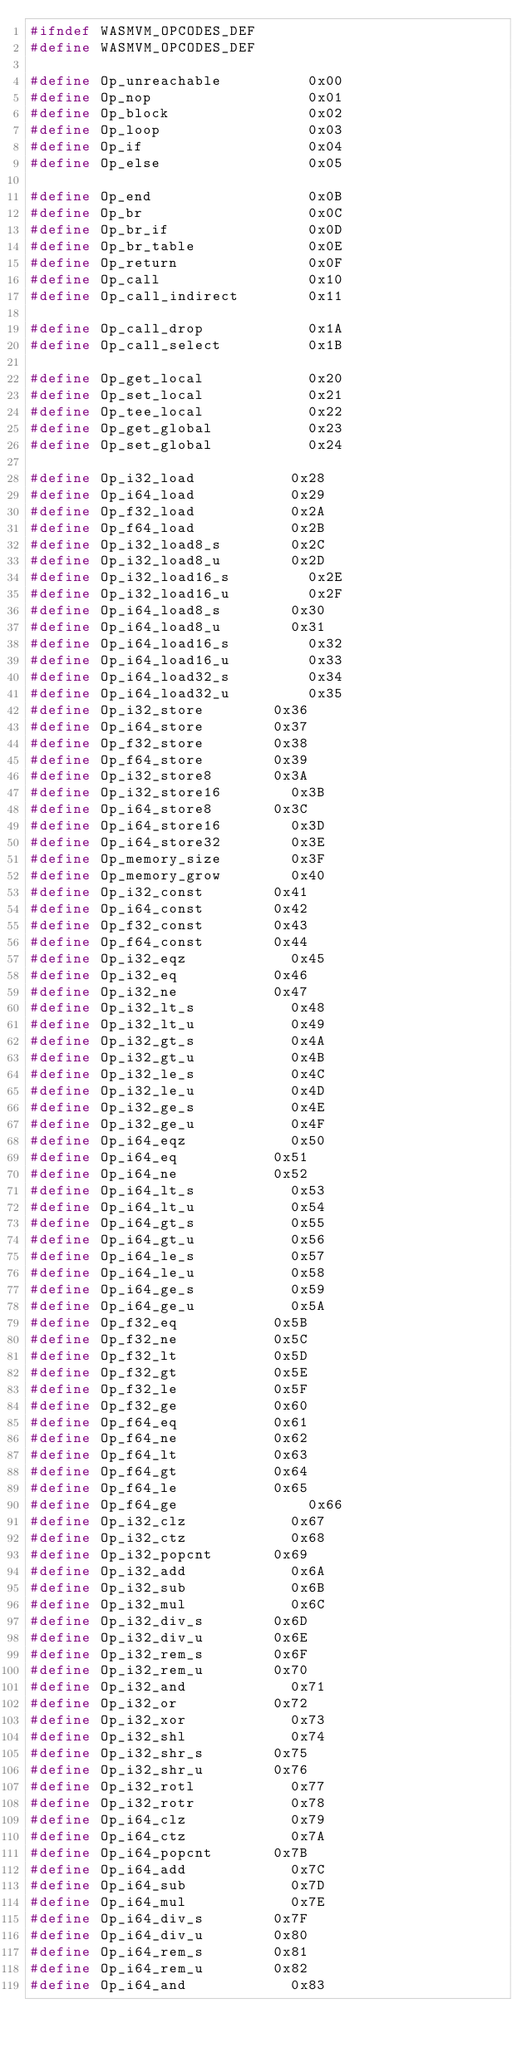<code> <loc_0><loc_0><loc_500><loc_500><_C_>#ifndef WASMVM_OPCODES_DEF
#define WASMVM_OPCODES_DEF

#define Op_unreachable          0x00
#define Op_nop                  0x01
#define Op_block                0x02
#define Op_loop                 0x03
#define Op_if                   0x04
#define Op_else                 0x05

#define Op_end                  0x0B
#define Op_br                   0x0C
#define Op_br_if                0x0D
#define Op_br_table             0x0E
#define Op_return               0x0F
#define Op_call                 0x10
#define Op_call_indirect        0x11

#define Op_call_drop            0x1A
#define Op_call_select          0x1B

#define Op_get_local            0x20
#define Op_set_local            0x21
#define Op_tee_local            0x22
#define Op_get_global           0x23
#define Op_set_global           0x24

#define Op_i32_load		        0x28
#define Op_i64_load		        0x29
#define Op_f32_load		        0x2A
#define Op_f64_load		        0x2B
#define Op_i32_load8_s		    0x2C
#define Op_i32_load8_u		    0x2D
#define Op_i32_load16_s	        0x2E
#define Op_i32_load16_u	        0x2F
#define Op_i64_load8_s		    0x30
#define Op_i64_load8_u		    0x31
#define Op_i64_load16_s	        0x32
#define Op_i64_load16_u	        0x33
#define Op_i64_load32_s	        0x34
#define Op_i64_load32_u	        0x35
#define Op_i32_store		    0x36
#define Op_i64_store		    0x37
#define Op_f32_store		    0x38
#define Op_f64_store		    0x39
#define Op_i32_store8		    0x3A
#define Op_i32_store16		    0x3B
#define Op_i64_store8		    0x3C
#define Op_i64_store16		    0x3D
#define Op_i64_store32		    0x3E
#define Op_memory_size		    0x3F
#define Op_memory_grow		    0x40
#define Op_i32_const		    0x41
#define Op_i64_const		    0x42
#define Op_f32_const		    0x43
#define Op_f64_const		    0x44
#define Op_i32_eqz		        0x45
#define Op_i32_eq		        0x46
#define Op_i32_ne		        0x47
#define Op_i32_lt_s		        0x48
#define Op_i32_lt_u		        0x49
#define Op_i32_gt_s		        0x4A
#define Op_i32_gt_u		        0x4B
#define Op_i32_le_s		        0x4C
#define Op_i32_le_u		        0x4D
#define Op_i32_ge_s		        0x4E
#define Op_i32_ge_u		        0x4F
#define Op_i64_eqz		        0x50
#define Op_i64_eq		        0x51
#define Op_i64_ne		        0x52
#define Op_i64_lt_s		        0x53
#define Op_i64_lt_u		        0x54
#define Op_i64_gt_s		        0x55
#define Op_i64_gt_u		        0x56
#define Op_i64_le_s		        0x57
#define Op_i64_le_u		        0x58
#define Op_i64_ge_s		        0x59
#define Op_i64_ge_u		        0x5A
#define Op_f32_eq		        0x5B
#define Op_f32_ne		        0x5C
#define Op_f32_lt		        0x5D
#define Op_f32_gt		        0x5E
#define Op_f32_le		        0x5F
#define Op_f32_ge		        0x60
#define Op_f64_eq		        0x61
#define Op_f64_ne		        0x62
#define Op_f64_lt		        0x63
#define Op_f64_gt		        0x64
#define Op_f64_le		        0x65
#define Op_f64_ge               0x66
#define Op_i32_clz		        0x67
#define Op_i32_ctz		        0x68
#define Op_i32_popcnt		    0x69
#define Op_i32_add		        0x6A
#define Op_i32_sub		        0x6B
#define Op_i32_mul		        0x6C
#define Op_i32_div_s		    0x6D
#define Op_i32_div_u		    0x6E
#define Op_i32_rem_s		    0x6F
#define Op_i32_rem_u		    0x70
#define Op_i32_and		        0x71
#define Op_i32_or		        0x72
#define Op_i32_xor		        0x73
#define Op_i32_shl		        0x74
#define Op_i32_shr_s		    0x75
#define Op_i32_shr_u		    0x76
#define Op_i32_rotl		        0x77
#define Op_i32_rotr		        0x78
#define Op_i64_clz		        0x79
#define Op_i64_ctz		        0x7A
#define Op_i64_popcnt		    0x7B
#define Op_i64_add		        0x7C
#define Op_i64_sub		        0x7D
#define Op_i64_mul		        0x7E
#define Op_i64_div_s		    0x7F
#define Op_i64_div_u		    0x80
#define Op_i64_rem_s		    0x81
#define Op_i64_rem_u		    0x82
#define Op_i64_and		        0x83</code> 